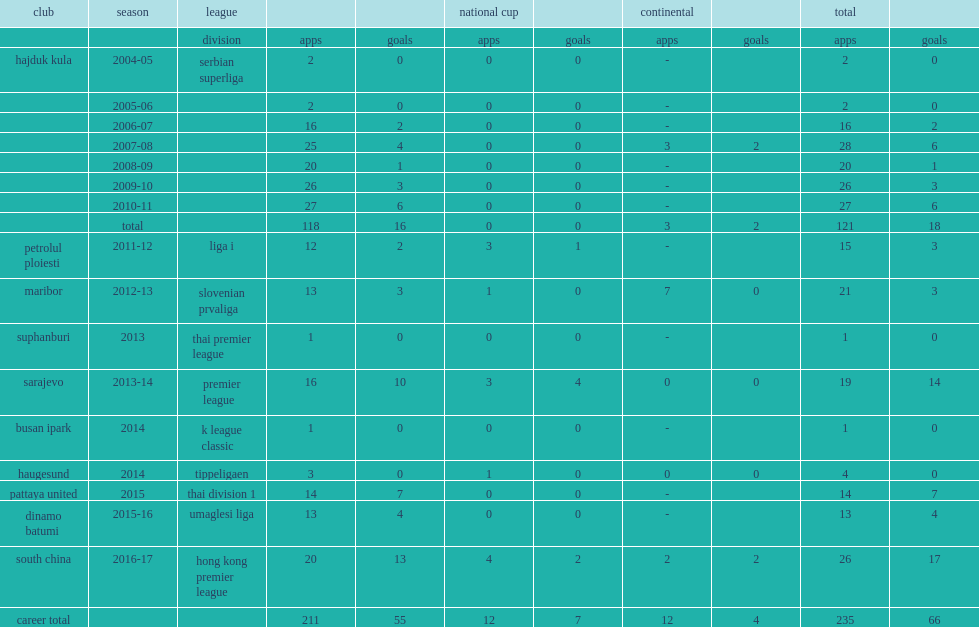Which club did komazec play for in 2014? Haugesund. 